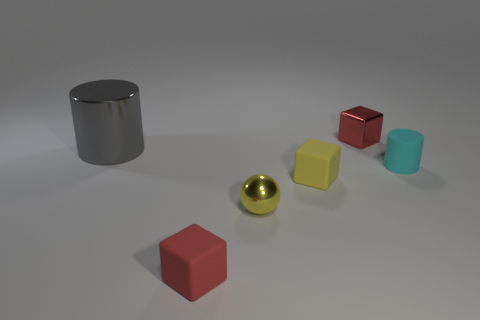What size is the red block that is behind the tiny rubber thing that is in front of the yellow matte thing? The red block positioned behind the small rubber ball and in front of the yellow matte cube appears to be medium-sized relative to the other objects in the image. 